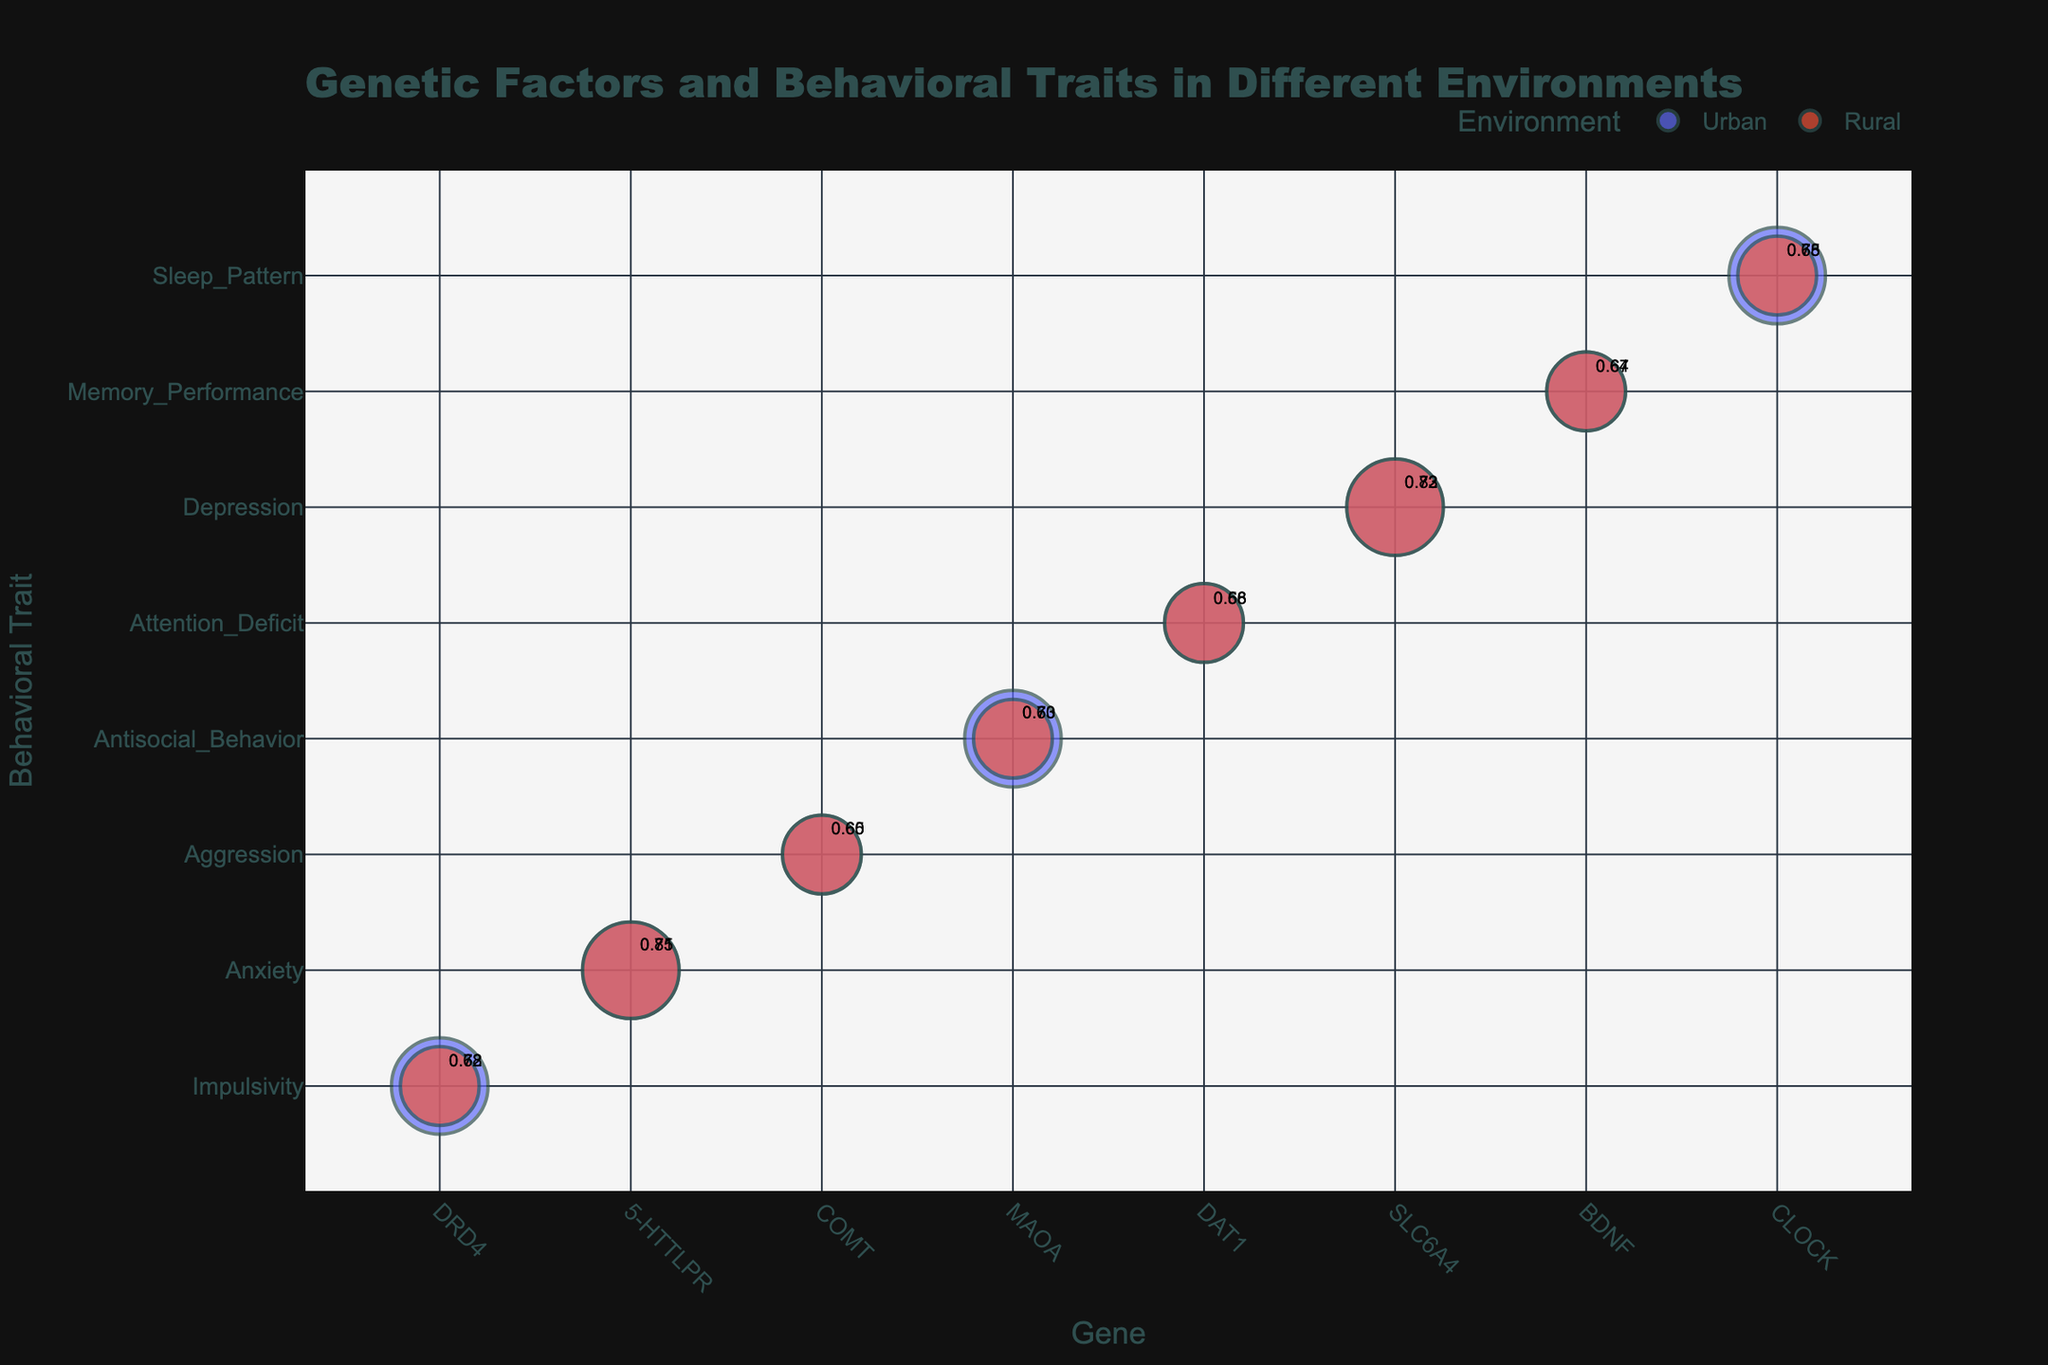What is the most correlated genetic factor with Anxiety in an urban environment? By looking at the bubble chart, we find the Anxiety trait in the y-axis and look for the respective urban environment category. The size and color of the bubbles will help identify the genetic factors. The highest correlation, 0.81, is found for the 5-HTTLPR gene in an urban environment.
Answer: 5-HTTLPR Which environment shows a higher correlation for the IMPULSIVITY trait, Urban or Rural? First, locate the Impulsivity trait on the y-axis. Then, compare the sizes of the bubbles, one for the urban and one for the rural environments. The correlation for the Urban environment is 0.72, while for the Rural environment, it is 0.68.
Answer: Urban How many genes are analyzed in the figure? Count the distinct number of genes labeled along the x-axis of the bubble chart. The genes are DRD4, 5-HTTLPR, COMT, MAOA, DAT1, SLC6A4, BDNF, and CLOCK.
Answer: 8 Which trait and environment combination has the lowest correlation? Scan through all the bubbles for the smallest numerical value in the 'Correlation' data shown on the bubble. The lowest correlation is 0.58, which corresponds to the DAT1 gene and Attention_Deficit trait in a rural environment.
Answer: Attention_Deficit in Rural Compare the importance of the SLC6A4 gene in urban and rural environments for the Depression trait. Locate the Depression trait and find the importance levels for both environments. The importance for SLC6A4 in an Urban environment is High, and it's also High in a Rural environment.
Answer: They are equal (High) Which behavioral trait is correlated more strongly with the MAOA gene in urban environments? Identify the Urban environment bubbles for the MAOA gene and compare the correlation values. The traits are Antisocial_Behavior with a correlation of 0.70.
Answer: Antisocial_Behavior What is the average correlation value for the Behavioral Traits influenced by the COMT gene? Locate all correlation values for the traits influenced by the COMT gene. These are Aggression (Urban 0.65, Rural 0.60). Average them: (0.65 + 0.60) / 2 = 0.625.
Answer: 0.625 Which behavioral trait has a higher correlation with the BDNF gene: Memory_Performance in Urban or Rural environments? Locate the Memory_Performance trait and compare the correlation values of Urban (0.67) and Rural (0.64) environments. The urban environment shows a higher correlation.
Answer: Urban Which genes show high importance in both environments, and for which traits? Find all the bubbles marked with High importance for both urban and rural environments. They are 5-HTTLPR (Anxiety), SLC6A4 (Depression).
Answer: 5-HTTLPR (Anxiety), SLC6A4 (Depression) How does the correlation of the DRD4 gene with Impulsivity compare between Urban and Rural environments? Locate the Impulsivity trait for the DRD4 gene and compare the correlation values for Urban (0.72) and Rural (0.68). The correlation is higher in Urban environments by 0.04.
Answer: Urban is higher 